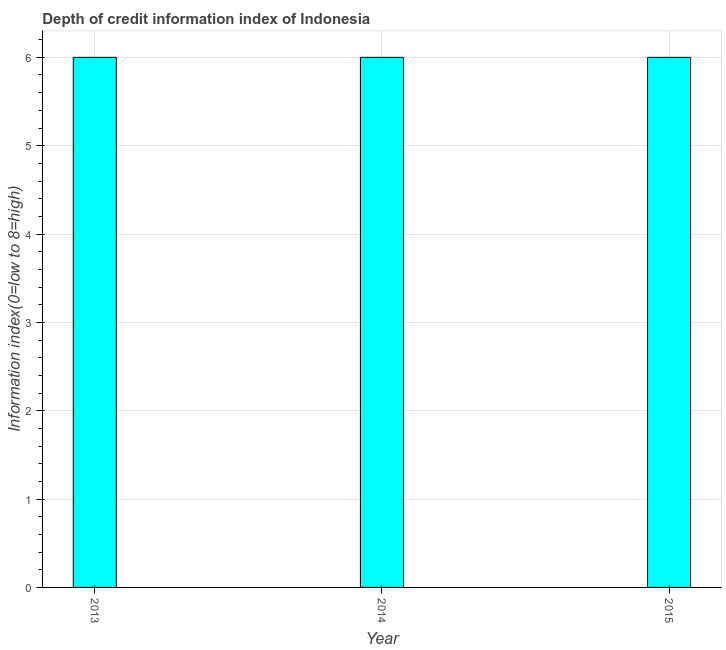What is the title of the graph?
Offer a very short reply. Depth of credit information index of Indonesia. What is the label or title of the X-axis?
Make the answer very short. Year. What is the label or title of the Y-axis?
Your answer should be very brief. Information index(0=low to 8=high). In which year was the depth of credit information index minimum?
Give a very brief answer. 2013. What is the average depth of credit information index per year?
Offer a terse response. 6. What is the median depth of credit information index?
Ensure brevity in your answer.  6. Do a majority of the years between 2015 and 2013 (inclusive) have depth of credit information index greater than 3.6 ?
Make the answer very short. Yes. Is the depth of credit information index in 2013 less than that in 2015?
Give a very brief answer. No. Is the difference between the depth of credit information index in 2013 and 2015 greater than the difference between any two years?
Make the answer very short. Yes. What is the difference between the highest and the lowest depth of credit information index?
Provide a succinct answer. 0. In how many years, is the depth of credit information index greater than the average depth of credit information index taken over all years?
Keep it short and to the point. 0. Are all the bars in the graph horizontal?
Offer a very short reply. No. What is the Information index(0=low to 8=high) in 2014?
Provide a succinct answer. 6. What is the difference between the Information index(0=low to 8=high) in 2013 and 2015?
Your answer should be very brief. 0. What is the difference between the Information index(0=low to 8=high) in 2014 and 2015?
Give a very brief answer. 0. What is the ratio of the Information index(0=low to 8=high) in 2013 to that in 2014?
Ensure brevity in your answer.  1. What is the ratio of the Information index(0=low to 8=high) in 2013 to that in 2015?
Provide a succinct answer. 1. 